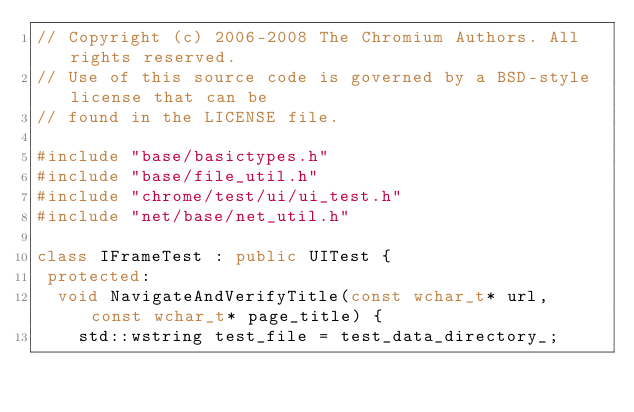<code> <loc_0><loc_0><loc_500><loc_500><_C++_>// Copyright (c) 2006-2008 The Chromium Authors. All rights reserved.
// Use of this source code is governed by a BSD-style license that can be
// found in the LICENSE file.

#include "base/basictypes.h"
#include "base/file_util.h"
#include "chrome/test/ui/ui_test.h"
#include "net/base/net_util.h"

class IFrameTest : public UITest {
 protected:
  void NavigateAndVerifyTitle(const wchar_t* url, const wchar_t* page_title) {
    std::wstring test_file = test_data_directory_;</code> 